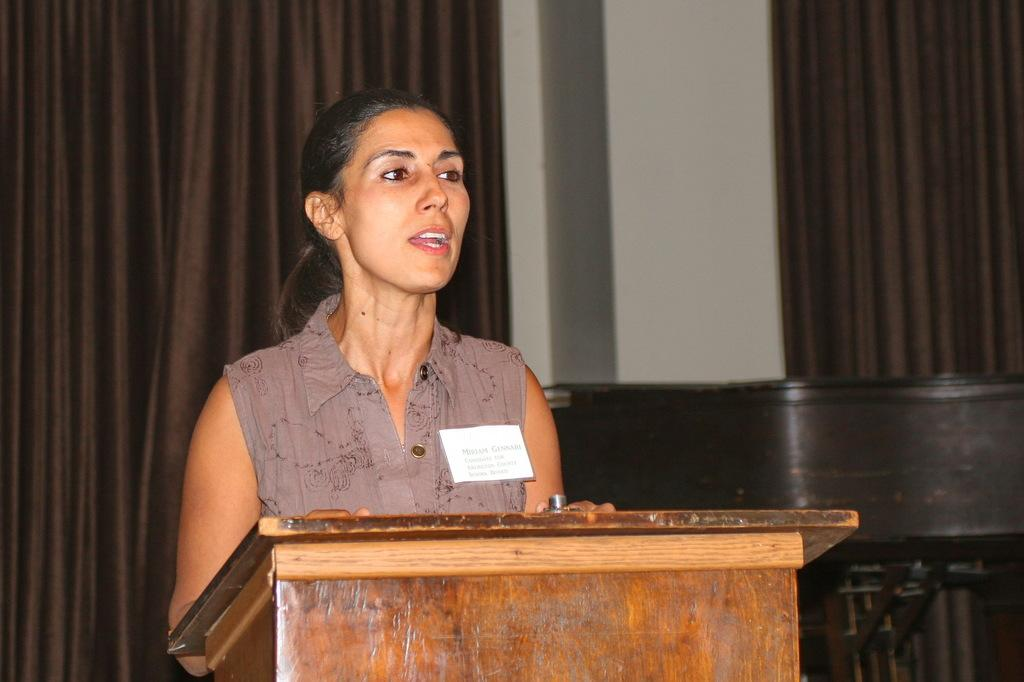Who is the main subject in the image? There is a woman in the image. What object is present in the image that might be used for public speaking? There is a podium in the image. What type of decorative elements can be seen in the background of the image? There are curtains in the background of the image. What type of architectural feature is visible in the background of the image? There is a wall in the background of the image. What type of invention is being demonstrated by the woman in the image? There is no invention being demonstrated in the image; it only shows a woman standing near a podium with curtains and a wall in the background. 